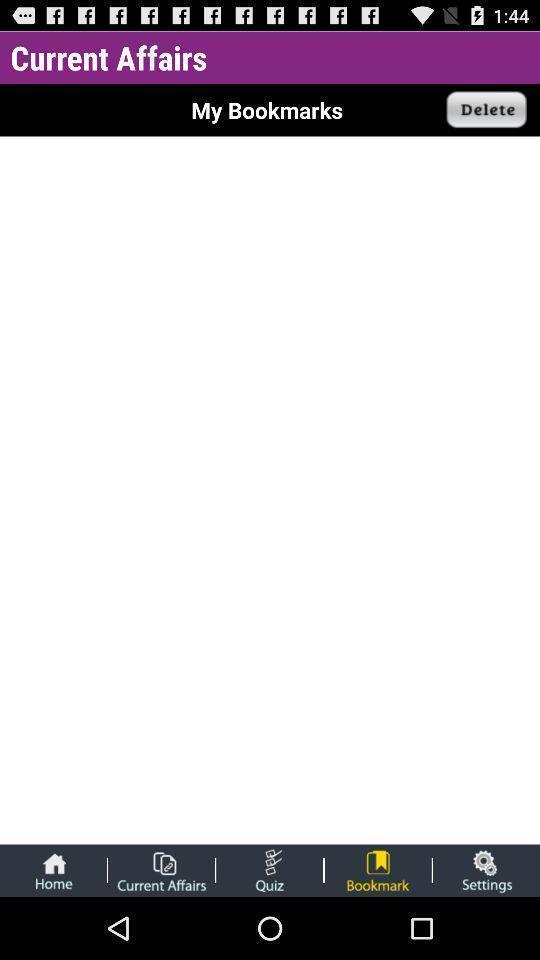Summarize the information in this screenshot. Page displaying empty with many options. 